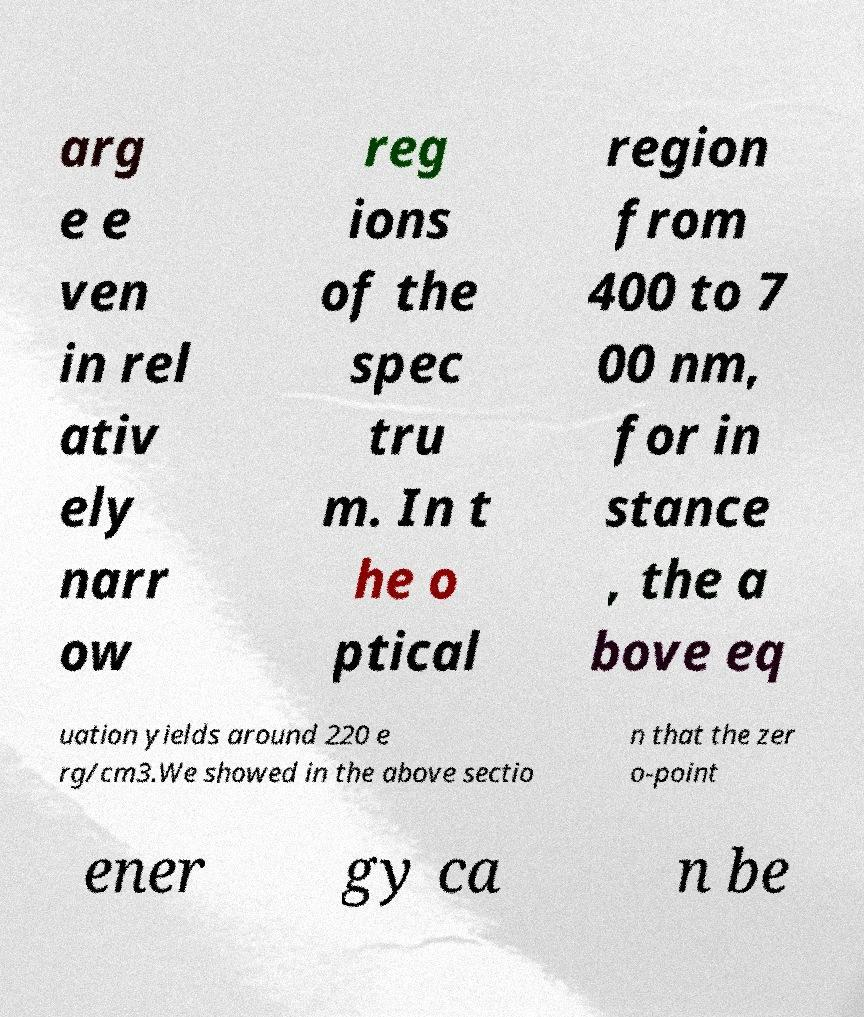Can you accurately transcribe the text from the provided image for me? arg e e ven in rel ativ ely narr ow reg ions of the spec tru m. In t he o ptical region from 400 to 7 00 nm, for in stance , the a bove eq uation yields around 220 e rg/cm3.We showed in the above sectio n that the zer o-point ener gy ca n be 